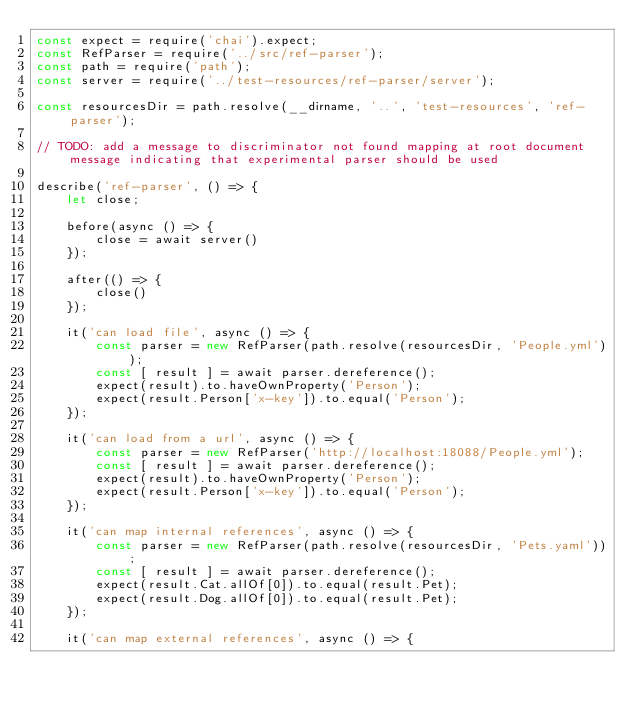<code> <loc_0><loc_0><loc_500><loc_500><_JavaScript_>const expect = require('chai').expect;
const RefParser = require('../src/ref-parser');
const path = require('path');
const server = require('../test-resources/ref-parser/server');

const resourcesDir = path.resolve(__dirname, '..', 'test-resources', 'ref-parser');

// TODO: add a message to discriminator not found mapping at root document message indicating that experimental parser should be used

describe('ref-parser', () => {
    let close;

    before(async () => {
        close = await server()
    });

    after(() => {
        close()
    });

    it('can load file', async () => {
        const parser = new RefParser(path.resolve(resourcesDir, 'People.yml'));
        const [ result ] = await parser.dereference();
        expect(result).to.haveOwnProperty('Person');
        expect(result.Person['x-key']).to.equal('Person');
    });

    it('can load from a url', async () => {
        const parser = new RefParser('http://localhost:18088/People.yml');
        const [ result ] = await parser.dereference();
        expect(result).to.haveOwnProperty('Person');
        expect(result.Person['x-key']).to.equal('Person');
    });

    it('can map internal references', async () => {
        const parser = new RefParser(path.resolve(resourcesDir, 'Pets.yaml'));
        const [ result ] = await parser.dereference();
        expect(result.Cat.allOf[0]).to.equal(result.Pet);
        expect(result.Dog.allOf[0]).to.equal(result.Pet);
    });

    it('can map external references', async () => {</code> 